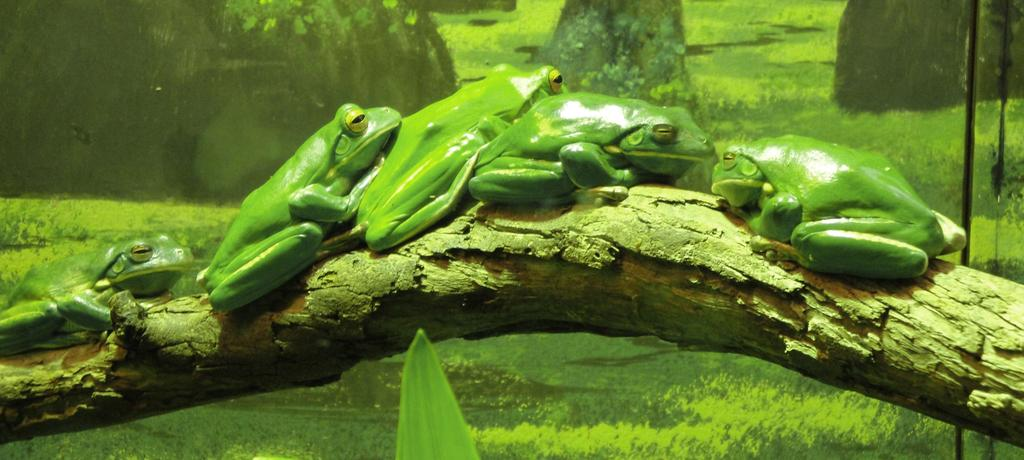What type of animals are in the image? There are green frogs in the image. Where are the frogs located? The frogs are on a branch. What color is the background of the image? The background of the image is green. What other green object can be seen in the image? There is a green leaf at the bottom portion of the image. What type of glove is being used to clean the dirt off the frogs in the image? There is no glove or dirt present in the image; it features green frogs on a branch with a green background and a green leaf. 